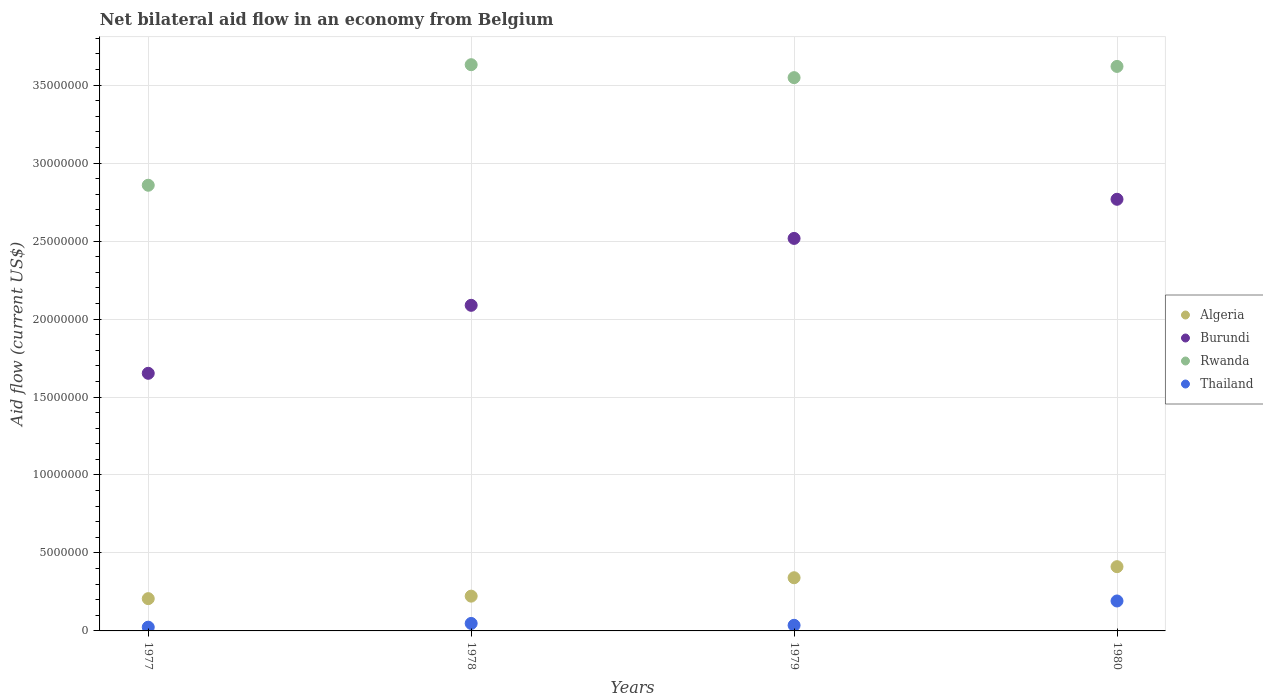What is the net bilateral aid flow in Rwanda in 1979?
Offer a very short reply. 3.55e+07. Across all years, what is the maximum net bilateral aid flow in Rwanda?
Your answer should be compact. 3.63e+07. Across all years, what is the minimum net bilateral aid flow in Burundi?
Make the answer very short. 1.65e+07. In which year was the net bilateral aid flow in Rwanda maximum?
Keep it short and to the point. 1978. In which year was the net bilateral aid flow in Burundi minimum?
Ensure brevity in your answer.  1977. What is the total net bilateral aid flow in Thailand in the graph?
Ensure brevity in your answer.  3.00e+06. What is the difference between the net bilateral aid flow in Algeria in 1977 and that in 1979?
Your answer should be compact. -1.34e+06. What is the difference between the net bilateral aid flow in Algeria in 1978 and the net bilateral aid flow in Burundi in 1977?
Keep it short and to the point. -1.43e+07. What is the average net bilateral aid flow in Thailand per year?
Keep it short and to the point. 7.50e+05. In the year 1979, what is the difference between the net bilateral aid flow in Algeria and net bilateral aid flow in Rwanda?
Your answer should be very brief. -3.21e+07. In how many years, is the net bilateral aid flow in Burundi greater than 22000000 US$?
Give a very brief answer. 2. What is the ratio of the net bilateral aid flow in Thailand in 1978 to that in 1979?
Your answer should be compact. 1.33. Is the difference between the net bilateral aid flow in Algeria in 1978 and 1979 greater than the difference between the net bilateral aid flow in Rwanda in 1978 and 1979?
Your answer should be very brief. No. What is the difference between the highest and the second highest net bilateral aid flow in Burundi?
Your answer should be compact. 2.51e+06. What is the difference between the highest and the lowest net bilateral aid flow in Thailand?
Keep it short and to the point. 1.68e+06. In how many years, is the net bilateral aid flow in Burundi greater than the average net bilateral aid flow in Burundi taken over all years?
Give a very brief answer. 2. Is the sum of the net bilateral aid flow in Algeria in 1977 and 1980 greater than the maximum net bilateral aid flow in Thailand across all years?
Ensure brevity in your answer.  Yes. Is it the case that in every year, the sum of the net bilateral aid flow in Algeria and net bilateral aid flow in Thailand  is greater than the net bilateral aid flow in Rwanda?
Provide a succinct answer. No. Does the net bilateral aid flow in Rwanda monotonically increase over the years?
Give a very brief answer. No. Is the net bilateral aid flow in Burundi strictly greater than the net bilateral aid flow in Thailand over the years?
Give a very brief answer. Yes. How many dotlines are there?
Make the answer very short. 4. Does the graph contain any zero values?
Offer a terse response. No. Does the graph contain grids?
Give a very brief answer. Yes. What is the title of the graph?
Your response must be concise. Net bilateral aid flow in an economy from Belgium. Does "Curacao" appear as one of the legend labels in the graph?
Offer a very short reply. No. What is the Aid flow (current US$) in Algeria in 1977?
Provide a succinct answer. 2.07e+06. What is the Aid flow (current US$) in Burundi in 1977?
Give a very brief answer. 1.65e+07. What is the Aid flow (current US$) in Rwanda in 1977?
Make the answer very short. 2.86e+07. What is the Aid flow (current US$) in Thailand in 1977?
Give a very brief answer. 2.40e+05. What is the Aid flow (current US$) of Algeria in 1978?
Your answer should be very brief. 2.23e+06. What is the Aid flow (current US$) of Burundi in 1978?
Give a very brief answer. 2.09e+07. What is the Aid flow (current US$) of Rwanda in 1978?
Keep it short and to the point. 3.63e+07. What is the Aid flow (current US$) of Thailand in 1978?
Make the answer very short. 4.80e+05. What is the Aid flow (current US$) in Algeria in 1979?
Provide a succinct answer. 3.41e+06. What is the Aid flow (current US$) in Burundi in 1979?
Offer a terse response. 2.52e+07. What is the Aid flow (current US$) of Rwanda in 1979?
Your response must be concise. 3.55e+07. What is the Aid flow (current US$) in Thailand in 1979?
Make the answer very short. 3.60e+05. What is the Aid flow (current US$) of Algeria in 1980?
Make the answer very short. 4.12e+06. What is the Aid flow (current US$) of Burundi in 1980?
Your answer should be very brief. 2.77e+07. What is the Aid flow (current US$) of Rwanda in 1980?
Offer a very short reply. 3.62e+07. What is the Aid flow (current US$) of Thailand in 1980?
Provide a short and direct response. 1.92e+06. Across all years, what is the maximum Aid flow (current US$) in Algeria?
Ensure brevity in your answer.  4.12e+06. Across all years, what is the maximum Aid flow (current US$) of Burundi?
Keep it short and to the point. 2.77e+07. Across all years, what is the maximum Aid flow (current US$) of Rwanda?
Your response must be concise. 3.63e+07. Across all years, what is the maximum Aid flow (current US$) in Thailand?
Offer a very short reply. 1.92e+06. Across all years, what is the minimum Aid flow (current US$) in Algeria?
Keep it short and to the point. 2.07e+06. Across all years, what is the minimum Aid flow (current US$) in Burundi?
Keep it short and to the point. 1.65e+07. Across all years, what is the minimum Aid flow (current US$) of Rwanda?
Your response must be concise. 2.86e+07. What is the total Aid flow (current US$) of Algeria in the graph?
Provide a short and direct response. 1.18e+07. What is the total Aid flow (current US$) in Burundi in the graph?
Ensure brevity in your answer.  9.02e+07. What is the total Aid flow (current US$) of Rwanda in the graph?
Provide a short and direct response. 1.37e+08. What is the difference between the Aid flow (current US$) of Burundi in 1977 and that in 1978?
Keep it short and to the point. -4.36e+06. What is the difference between the Aid flow (current US$) of Rwanda in 1977 and that in 1978?
Offer a terse response. -7.73e+06. What is the difference between the Aid flow (current US$) in Thailand in 1977 and that in 1978?
Provide a succinct answer. -2.40e+05. What is the difference between the Aid flow (current US$) in Algeria in 1977 and that in 1979?
Ensure brevity in your answer.  -1.34e+06. What is the difference between the Aid flow (current US$) of Burundi in 1977 and that in 1979?
Give a very brief answer. -8.65e+06. What is the difference between the Aid flow (current US$) in Rwanda in 1977 and that in 1979?
Your answer should be compact. -6.90e+06. What is the difference between the Aid flow (current US$) of Algeria in 1977 and that in 1980?
Offer a terse response. -2.05e+06. What is the difference between the Aid flow (current US$) of Burundi in 1977 and that in 1980?
Give a very brief answer. -1.12e+07. What is the difference between the Aid flow (current US$) in Rwanda in 1977 and that in 1980?
Provide a succinct answer. -7.62e+06. What is the difference between the Aid flow (current US$) in Thailand in 1977 and that in 1980?
Provide a short and direct response. -1.68e+06. What is the difference between the Aid flow (current US$) of Algeria in 1978 and that in 1979?
Provide a short and direct response. -1.18e+06. What is the difference between the Aid flow (current US$) in Burundi in 1978 and that in 1979?
Make the answer very short. -4.29e+06. What is the difference between the Aid flow (current US$) of Rwanda in 1978 and that in 1979?
Make the answer very short. 8.30e+05. What is the difference between the Aid flow (current US$) in Thailand in 1978 and that in 1979?
Keep it short and to the point. 1.20e+05. What is the difference between the Aid flow (current US$) in Algeria in 1978 and that in 1980?
Keep it short and to the point. -1.89e+06. What is the difference between the Aid flow (current US$) of Burundi in 1978 and that in 1980?
Your response must be concise. -6.80e+06. What is the difference between the Aid flow (current US$) of Thailand in 1978 and that in 1980?
Your response must be concise. -1.44e+06. What is the difference between the Aid flow (current US$) in Algeria in 1979 and that in 1980?
Offer a terse response. -7.10e+05. What is the difference between the Aid flow (current US$) of Burundi in 1979 and that in 1980?
Offer a terse response. -2.51e+06. What is the difference between the Aid flow (current US$) of Rwanda in 1979 and that in 1980?
Keep it short and to the point. -7.20e+05. What is the difference between the Aid flow (current US$) in Thailand in 1979 and that in 1980?
Your answer should be very brief. -1.56e+06. What is the difference between the Aid flow (current US$) in Algeria in 1977 and the Aid flow (current US$) in Burundi in 1978?
Give a very brief answer. -1.88e+07. What is the difference between the Aid flow (current US$) in Algeria in 1977 and the Aid flow (current US$) in Rwanda in 1978?
Ensure brevity in your answer.  -3.42e+07. What is the difference between the Aid flow (current US$) of Algeria in 1977 and the Aid flow (current US$) of Thailand in 1978?
Your answer should be very brief. 1.59e+06. What is the difference between the Aid flow (current US$) in Burundi in 1977 and the Aid flow (current US$) in Rwanda in 1978?
Make the answer very short. -1.98e+07. What is the difference between the Aid flow (current US$) of Burundi in 1977 and the Aid flow (current US$) of Thailand in 1978?
Your answer should be very brief. 1.60e+07. What is the difference between the Aid flow (current US$) in Rwanda in 1977 and the Aid flow (current US$) in Thailand in 1978?
Provide a succinct answer. 2.81e+07. What is the difference between the Aid flow (current US$) of Algeria in 1977 and the Aid flow (current US$) of Burundi in 1979?
Your answer should be very brief. -2.31e+07. What is the difference between the Aid flow (current US$) in Algeria in 1977 and the Aid flow (current US$) in Rwanda in 1979?
Offer a terse response. -3.34e+07. What is the difference between the Aid flow (current US$) in Algeria in 1977 and the Aid flow (current US$) in Thailand in 1979?
Your answer should be compact. 1.71e+06. What is the difference between the Aid flow (current US$) of Burundi in 1977 and the Aid flow (current US$) of Rwanda in 1979?
Make the answer very short. -1.90e+07. What is the difference between the Aid flow (current US$) of Burundi in 1977 and the Aid flow (current US$) of Thailand in 1979?
Ensure brevity in your answer.  1.62e+07. What is the difference between the Aid flow (current US$) of Rwanda in 1977 and the Aid flow (current US$) of Thailand in 1979?
Your answer should be very brief. 2.82e+07. What is the difference between the Aid flow (current US$) in Algeria in 1977 and the Aid flow (current US$) in Burundi in 1980?
Your answer should be very brief. -2.56e+07. What is the difference between the Aid flow (current US$) in Algeria in 1977 and the Aid flow (current US$) in Rwanda in 1980?
Ensure brevity in your answer.  -3.41e+07. What is the difference between the Aid flow (current US$) in Burundi in 1977 and the Aid flow (current US$) in Rwanda in 1980?
Keep it short and to the point. -1.97e+07. What is the difference between the Aid flow (current US$) in Burundi in 1977 and the Aid flow (current US$) in Thailand in 1980?
Your answer should be very brief. 1.46e+07. What is the difference between the Aid flow (current US$) in Rwanda in 1977 and the Aid flow (current US$) in Thailand in 1980?
Provide a succinct answer. 2.67e+07. What is the difference between the Aid flow (current US$) of Algeria in 1978 and the Aid flow (current US$) of Burundi in 1979?
Give a very brief answer. -2.29e+07. What is the difference between the Aid flow (current US$) of Algeria in 1978 and the Aid flow (current US$) of Rwanda in 1979?
Your answer should be very brief. -3.32e+07. What is the difference between the Aid flow (current US$) in Algeria in 1978 and the Aid flow (current US$) in Thailand in 1979?
Your answer should be very brief. 1.87e+06. What is the difference between the Aid flow (current US$) of Burundi in 1978 and the Aid flow (current US$) of Rwanda in 1979?
Your answer should be compact. -1.46e+07. What is the difference between the Aid flow (current US$) of Burundi in 1978 and the Aid flow (current US$) of Thailand in 1979?
Your answer should be very brief. 2.05e+07. What is the difference between the Aid flow (current US$) of Rwanda in 1978 and the Aid flow (current US$) of Thailand in 1979?
Offer a terse response. 3.60e+07. What is the difference between the Aid flow (current US$) in Algeria in 1978 and the Aid flow (current US$) in Burundi in 1980?
Your response must be concise. -2.54e+07. What is the difference between the Aid flow (current US$) in Algeria in 1978 and the Aid flow (current US$) in Rwanda in 1980?
Your response must be concise. -3.40e+07. What is the difference between the Aid flow (current US$) of Algeria in 1978 and the Aid flow (current US$) of Thailand in 1980?
Offer a terse response. 3.10e+05. What is the difference between the Aid flow (current US$) of Burundi in 1978 and the Aid flow (current US$) of Rwanda in 1980?
Offer a terse response. -1.53e+07. What is the difference between the Aid flow (current US$) of Burundi in 1978 and the Aid flow (current US$) of Thailand in 1980?
Your answer should be compact. 1.90e+07. What is the difference between the Aid flow (current US$) of Rwanda in 1978 and the Aid flow (current US$) of Thailand in 1980?
Ensure brevity in your answer.  3.44e+07. What is the difference between the Aid flow (current US$) in Algeria in 1979 and the Aid flow (current US$) in Burundi in 1980?
Provide a short and direct response. -2.43e+07. What is the difference between the Aid flow (current US$) of Algeria in 1979 and the Aid flow (current US$) of Rwanda in 1980?
Ensure brevity in your answer.  -3.28e+07. What is the difference between the Aid flow (current US$) in Algeria in 1979 and the Aid flow (current US$) in Thailand in 1980?
Offer a terse response. 1.49e+06. What is the difference between the Aid flow (current US$) of Burundi in 1979 and the Aid flow (current US$) of Rwanda in 1980?
Provide a short and direct response. -1.10e+07. What is the difference between the Aid flow (current US$) of Burundi in 1979 and the Aid flow (current US$) of Thailand in 1980?
Your answer should be compact. 2.32e+07. What is the difference between the Aid flow (current US$) of Rwanda in 1979 and the Aid flow (current US$) of Thailand in 1980?
Provide a succinct answer. 3.36e+07. What is the average Aid flow (current US$) in Algeria per year?
Ensure brevity in your answer.  2.96e+06. What is the average Aid flow (current US$) in Burundi per year?
Provide a succinct answer. 2.26e+07. What is the average Aid flow (current US$) of Rwanda per year?
Make the answer very short. 3.41e+07. What is the average Aid flow (current US$) of Thailand per year?
Offer a very short reply. 7.50e+05. In the year 1977, what is the difference between the Aid flow (current US$) of Algeria and Aid flow (current US$) of Burundi?
Provide a succinct answer. -1.44e+07. In the year 1977, what is the difference between the Aid flow (current US$) of Algeria and Aid flow (current US$) of Rwanda?
Ensure brevity in your answer.  -2.65e+07. In the year 1977, what is the difference between the Aid flow (current US$) of Algeria and Aid flow (current US$) of Thailand?
Your response must be concise. 1.83e+06. In the year 1977, what is the difference between the Aid flow (current US$) in Burundi and Aid flow (current US$) in Rwanda?
Your answer should be compact. -1.21e+07. In the year 1977, what is the difference between the Aid flow (current US$) in Burundi and Aid flow (current US$) in Thailand?
Your response must be concise. 1.63e+07. In the year 1977, what is the difference between the Aid flow (current US$) in Rwanda and Aid flow (current US$) in Thailand?
Offer a terse response. 2.83e+07. In the year 1978, what is the difference between the Aid flow (current US$) of Algeria and Aid flow (current US$) of Burundi?
Offer a terse response. -1.86e+07. In the year 1978, what is the difference between the Aid flow (current US$) of Algeria and Aid flow (current US$) of Rwanda?
Ensure brevity in your answer.  -3.41e+07. In the year 1978, what is the difference between the Aid flow (current US$) of Algeria and Aid flow (current US$) of Thailand?
Your answer should be compact. 1.75e+06. In the year 1978, what is the difference between the Aid flow (current US$) of Burundi and Aid flow (current US$) of Rwanda?
Your response must be concise. -1.54e+07. In the year 1978, what is the difference between the Aid flow (current US$) in Burundi and Aid flow (current US$) in Thailand?
Make the answer very short. 2.04e+07. In the year 1978, what is the difference between the Aid flow (current US$) of Rwanda and Aid flow (current US$) of Thailand?
Your answer should be compact. 3.58e+07. In the year 1979, what is the difference between the Aid flow (current US$) of Algeria and Aid flow (current US$) of Burundi?
Ensure brevity in your answer.  -2.18e+07. In the year 1979, what is the difference between the Aid flow (current US$) in Algeria and Aid flow (current US$) in Rwanda?
Give a very brief answer. -3.21e+07. In the year 1979, what is the difference between the Aid flow (current US$) of Algeria and Aid flow (current US$) of Thailand?
Offer a very short reply. 3.05e+06. In the year 1979, what is the difference between the Aid flow (current US$) in Burundi and Aid flow (current US$) in Rwanda?
Provide a short and direct response. -1.03e+07. In the year 1979, what is the difference between the Aid flow (current US$) of Burundi and Aid flow (current US$) of Thailand?
Provide a succinct answer. 2.48e+07. In the year 1979, what is the difference between the Aid flow (current US$) in Rwanda and Aid flow (current US$) in Thailand?
Provide a succinct answer. 3.51e+07. In the year 1980, what is the difference between the Aid flow (current US$) in Algeria and Aid flow (current US$) in Burundi?
Offer a terse response. -2.36e+07. In the year 1980, what is the difference between the Aid flow (current US$) in Algeria and Aid flow (current US$) in Rwanda?
Ensure brevity in your answer.  -3.21e+07. In the year 1980, what is the difference between the Aid flow (current US$) of Algeria and Aid flow (current US$) of Thailand?
Provide a short and direct response. 2.20e+06. In the year 1980, what is the difference between the Aid flow (current US$) in Burundi and Aid flow (current US$) in Rwanda?
Your response must be concise. -8.52e+06. In the year 1980, what is the difference between the Aid flow (current US$) of Burundi and Aid flow (current US$) of Thailand?
Provide a succinct answer. 2.58e+07. In the year 1980, what is the difference between the Aid flow (current US$) in Rwanda and Aid flow (current US$) in Thailand?
Offer a very short reply. 3.43e+07. What is the ratio of the Aid flow (current US$) of Algeria in 1977 to that in 1978?
Give a very brief answer. 0.93. What is the ratio of the Aid flow (current US$) of Burundi in 1977 to that in 1978?
Your response must be concise. 0.79. What is the ratio of the Aid flow (current US$) in Rwanda in 1977 to that in 1978?
Offer a terse response. 0.79. What is the ratio of the Aid flow (current US$) in Thailand in 1977 to that in 1978?
Offer a very short reply. 0.5. What is the ratio of the Aid flow (current US$) in Algeria in 1977 to that in 1979?
Offer a terse response. 0.61. What is the ratio of the Aid flow (current US$) of Burundi in 1977 to that in 1979?
Provide a succinct answer. 0.66. What is the ratio of the Aid flow (current US$) in Rwanda in 1977 to that in 1979?
Provide a short and direct response. 0.81. What is the ratio of the Aid flow (current US$) in Algeria in 1977 to that in 1980?
Provide a succinct answer. 0.5. What is the ratio of the Aid flow (current US$) of Burundi in 1977 to that in 1980?
Your response must be concise. 0.6. What is the ratio of the Aid flow (current US$) of Rwanda in 1977 to that in 1980?
Give a very brief answer. 0.79. What is the ratio of the Aid flow (current US$) of Algeria in 1978 to that in 1979?
Offer a very short reply. 0.65. What is the ratio of the Aid flow (current US$) of Burundi in 1978 to that in 1979?
Give a very brief answer. 0.83. What is the ratio of the Aid flow (current US$) in Rwanda in 1978 to that in 1979?
Offer a very short reply. 1.02. What is the ratio of the Aid flow (current US$) in Thailand in 1978 to that in 1979?
Your response must be concise. 1.33. What is the ratio of the Aid flow (current US$) of Algeria in 1978 to that in 1980?
Offer a terse response. 0.54. What is the ratio of the Aid flow (current US$) in Burundi in 1978 to that in 1980?
Your answer should be very brief. 0.75. What is the ratio of the Aid flow (current US$) of Rwanda in 1978 to that in 1980?
Your response must be concise. 1. What is the ratio of the Aid flow (current US$) of Algeria in 1979 to that in 1980?
Ensure brevity in your answer.  0.83. What is the ratio of the Aid flow (current US$) of Burundi in 1979 to that in 1980?
Ensure brevity in your answer.  0.91. What is the ratio of the Aid flow (current US$) in Rwanda in 1979 to that in 1980?
Your answer should be compact. 0.98. What is the ratio of the Aid flow (current US$) in Thailand in 1979 to that in 1980?
Make the answer very short. 0.19. What is the difference between the highest and the second highest Aid flow (current US$) of Algeria?
Keep it short and to the point. 7.10e+05. What is the difference between the highest and the second highest Aid flow (current US$) in Burundi?
Keep it short and to the point. 2.51e+06. What is the difference between the highest and the second highest Aid flow (current US$) of Thailand?
Offer a terse response. 1.44e+06. What is the difference between the highest and the lowest Aid flow (current US$) in Algeria?
Your response must be concise. 2.05e+06. What is the difference between the highest and the lowest Aid flow (current US$) of Burundi?
Your answer should be compact. 1.12e+07. What is the difference between the highest and the lowest Aid flow (current US$) of Rwanda?
Offer a terse response. 7.73e+06. What is the difference between the highest and the lowest Aid flow (current US$) of Thailand?
Your answer should be compact. 1.68e+06. 